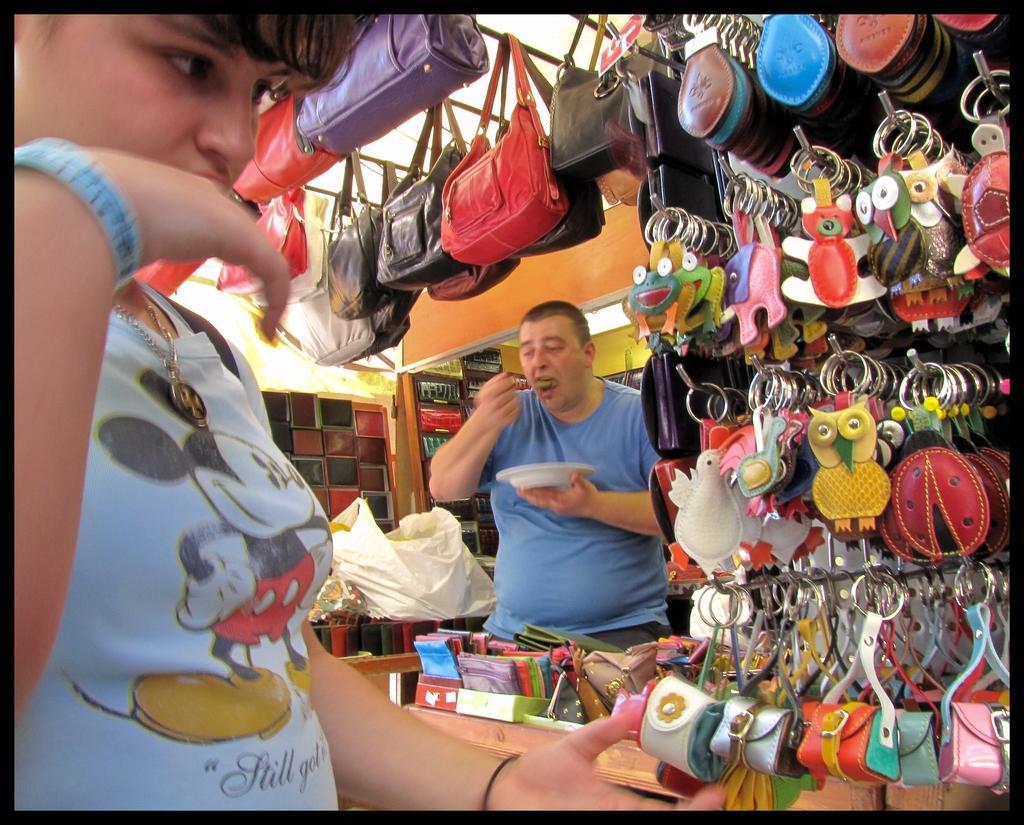In one or two sentences, can you explain what this image depicts? In this image there is a woman checking key chain in front of a handbag and the key chain store. 